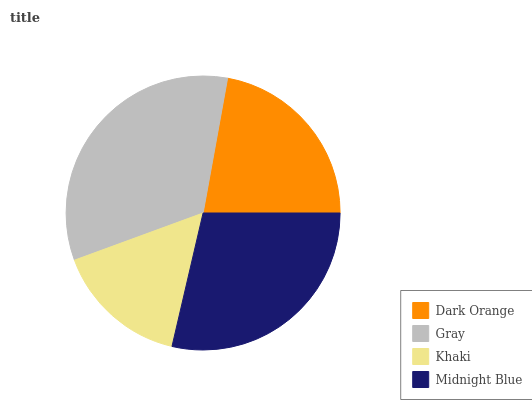Is Khaki the minimum?
Answer yes or no. Yes. Is Gray the maximum?
Answer yes or no. Yes. Is Gray the minimum?
Answer yes or no. No. Is Khaki the maximum?
Answer yes or no. No. Is Gray greater than Khaki?
Answer yes or no. Yes. Is Khaki less than Gray?
Answer yes or no. Yes. Is Khaki greater than Gray?
Answer yes or no. No. Is Gray less than Khaki?
Answer yes or no. No. Is Midnight Blue the high median?
Answer yes or no. Yes. Is Dark Orange the low median?
Answer yes or no. Yes. Is Dark Orange the high median?
Answer yes or no. No. Is Khaki the low median?
Answer yes or no. No. 